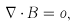<formula> <loc_0><loc_0><loc_500><loc_500>\nabla \cdot { B } = 0 ,</formula> 